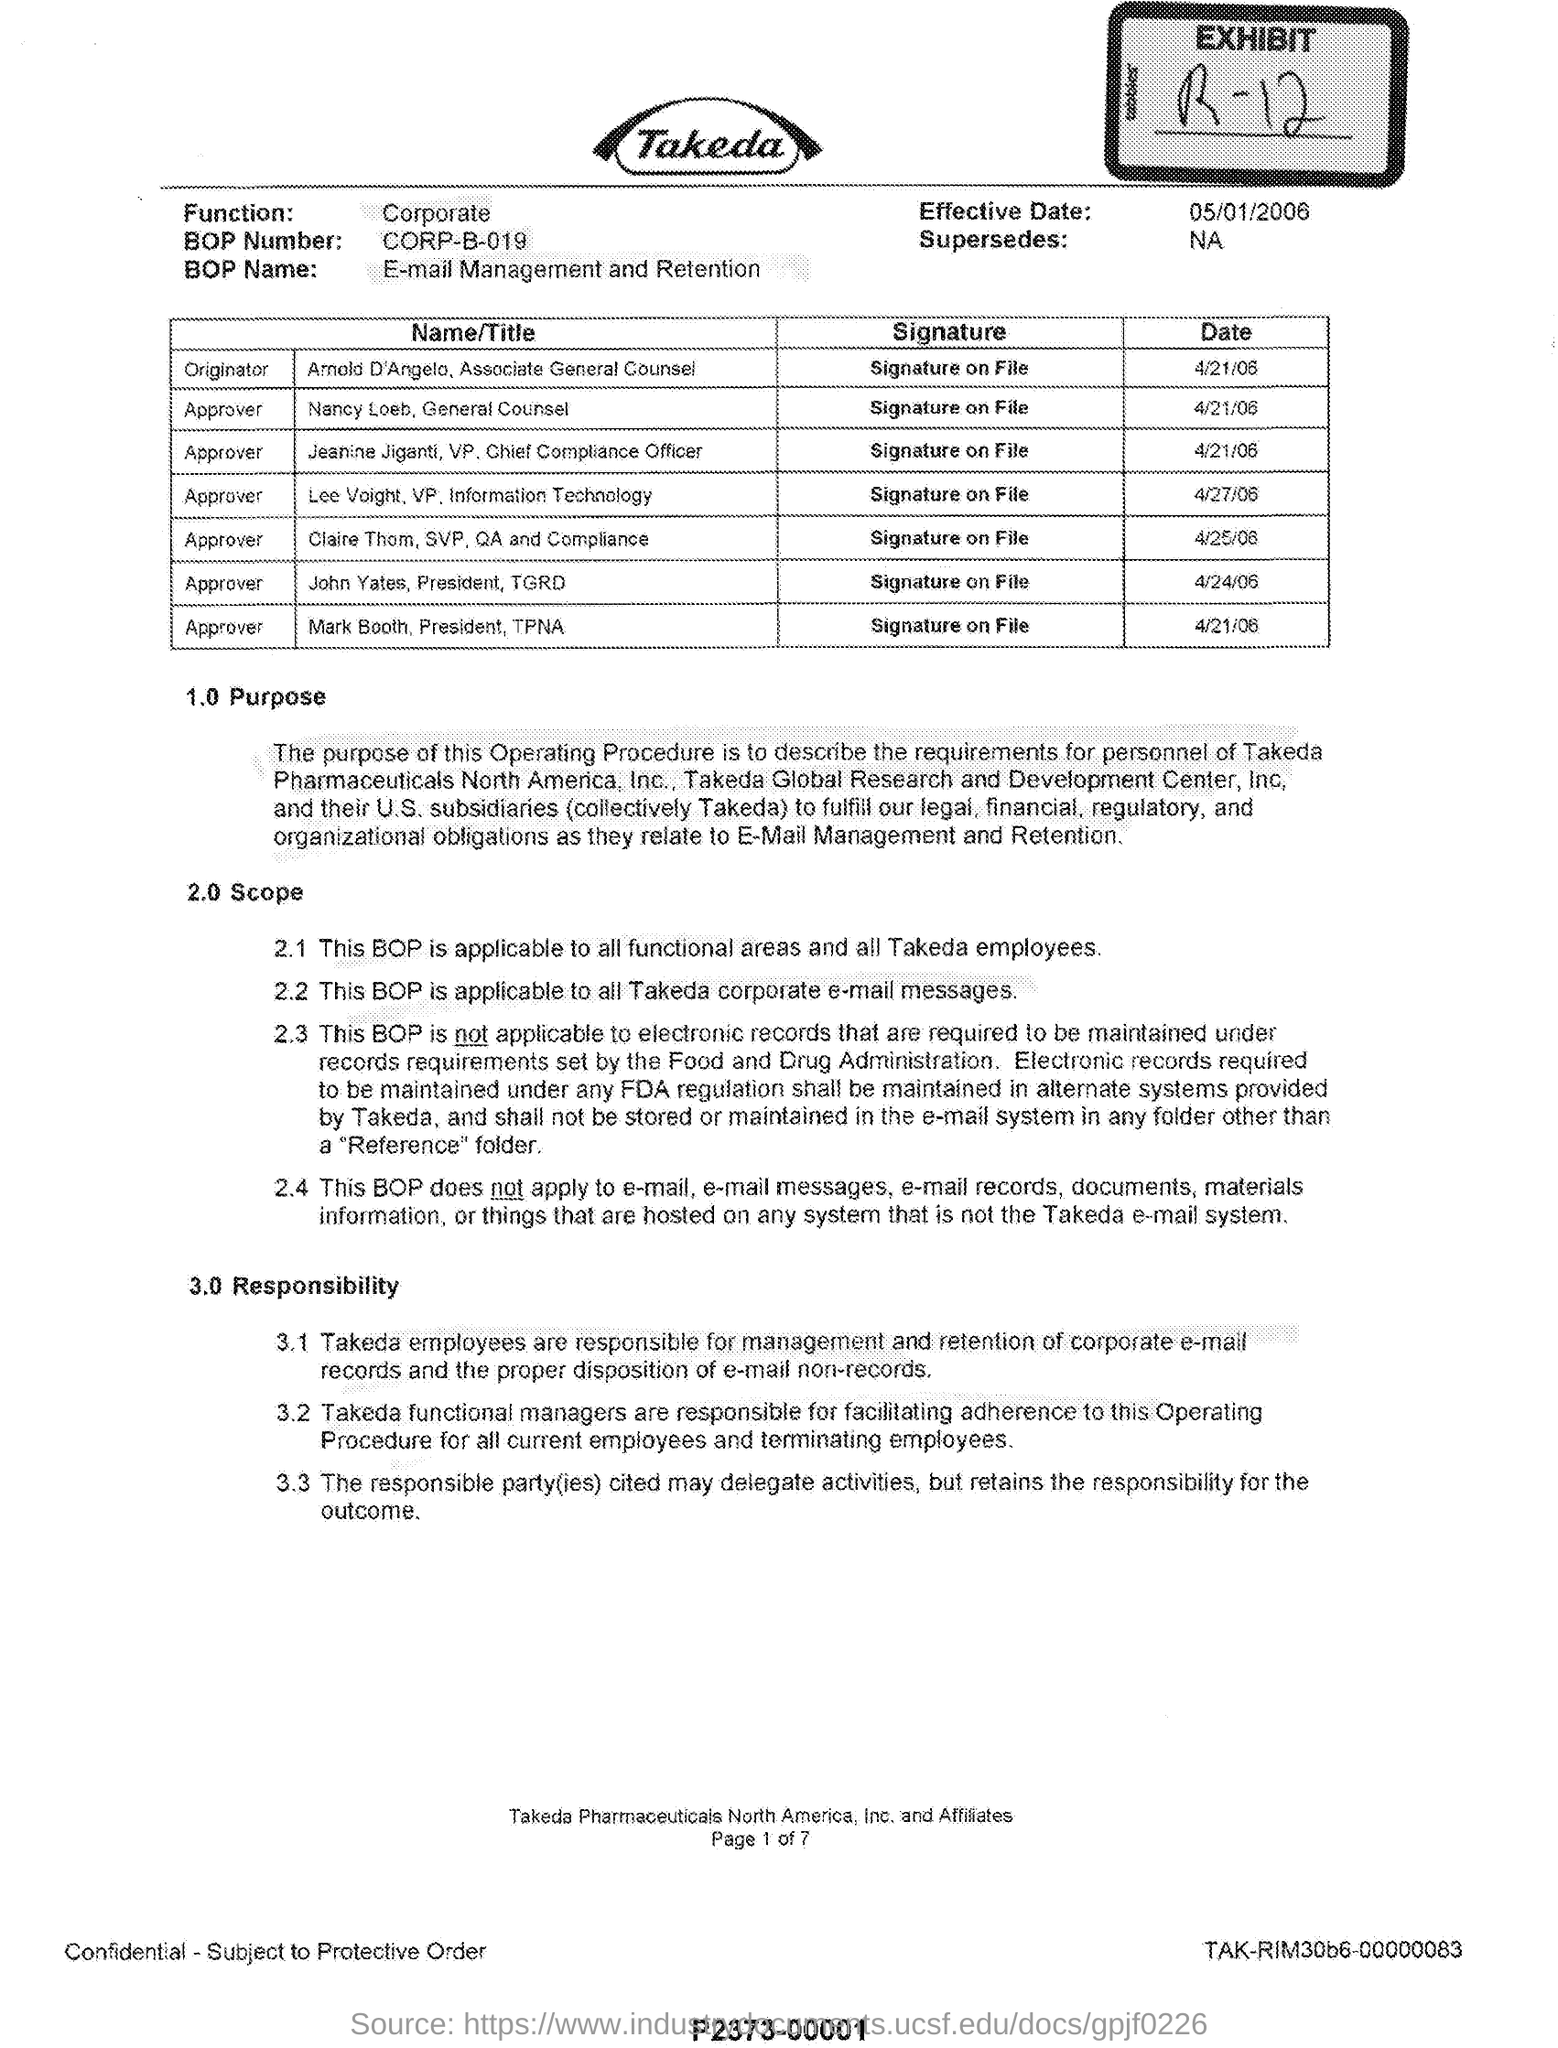What is the EXHIBIT number mentioned?
Provide a short and direct response. R-12. What is the BOP Number?
Your response must be concise. CORP-B-019. What is the Effective Date?
Your response must be concise. 05/01/2006. 